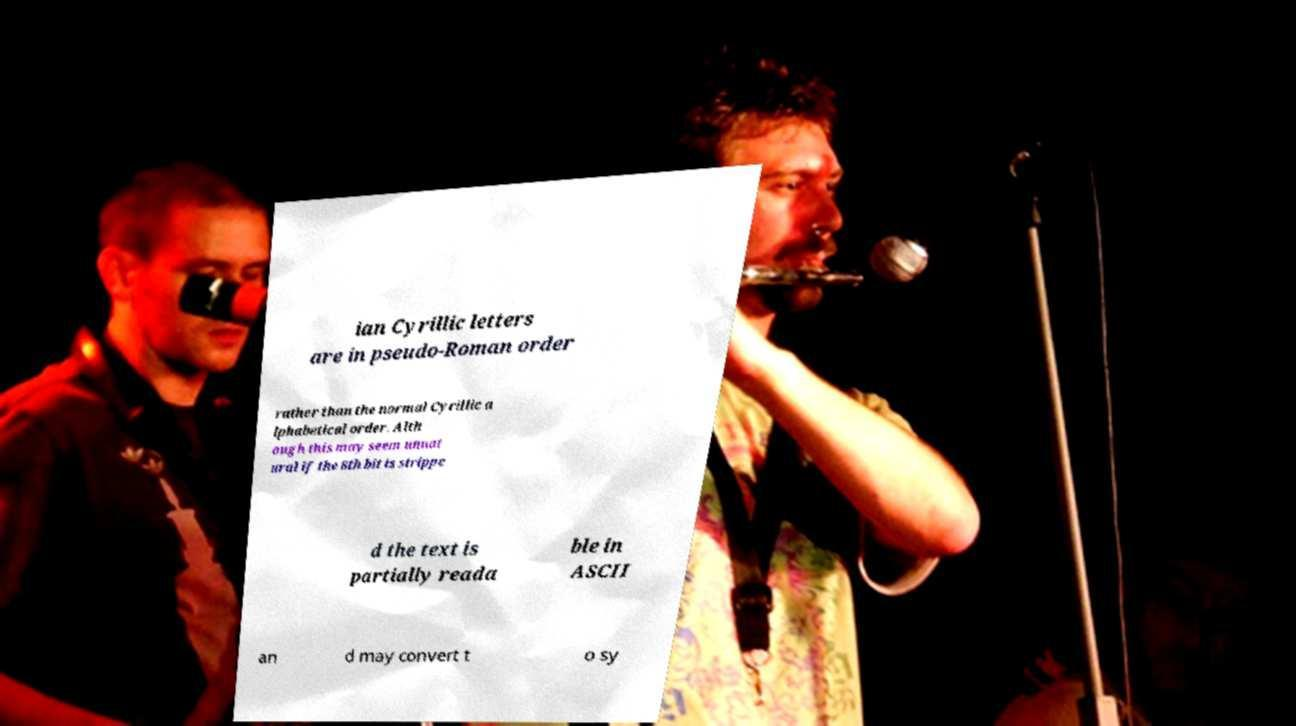Can you accurately transcribe the text from the provided image for me? ian Cyrillic letters are in pseudo-Roman order rather than the normal Cyrillic a lphabetical order. Alth ough this may seem unnat ural if the 8th bit is strippe d the text is partially reada ble in ASCII an d may convert t o sy 